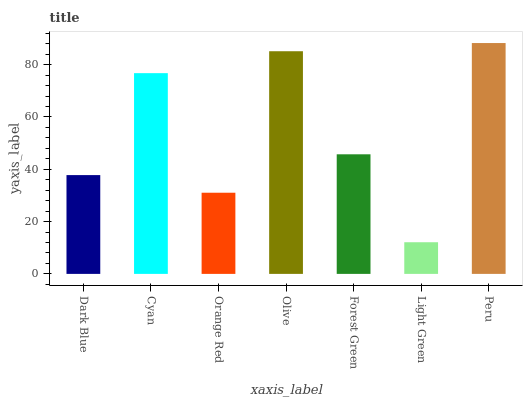Is Light Green the minimum?
Answer yes or no. Yes. Is Peru the maximum?
Answer yes or no. Yes. Is Cyan the minimum?
Answer yes or no. No. Is Cyan the maximum?
Answer yes or no. No. Is Cyan greater than Dark Blue?
Answer yes or no. Yes. Is Dark Blue less than Cyan?
Answer yes or no. Yes. Is Dark Blue greater than Cyan?
Answer yes or no. No. Is Cyan less than Dark Blue?
Answer yes or no. No. Is Forest Green the high median?
Answer yes or no. Yes. Is Forest Green the low median?
Answer yes or no. Yes. Is Orange Red the high median?
Answer yes or no. No. Is Olive the low median?
Answer yes or no. No. 